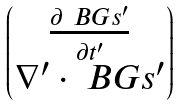<formula> <loc_0><loc_0><loc_500><loc_500>\begin{pmatrix} \frac { \partial \ B G s ^ { \prime } } { \partial t ^ { \prime } } \\ \nabla ^ { \prime } \cdot \ B G s ^ { \prime } \end{pmatrix}</formula> 